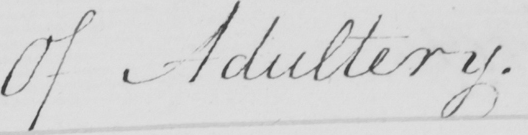What is written in this line of handwriting? Of Adultery . 